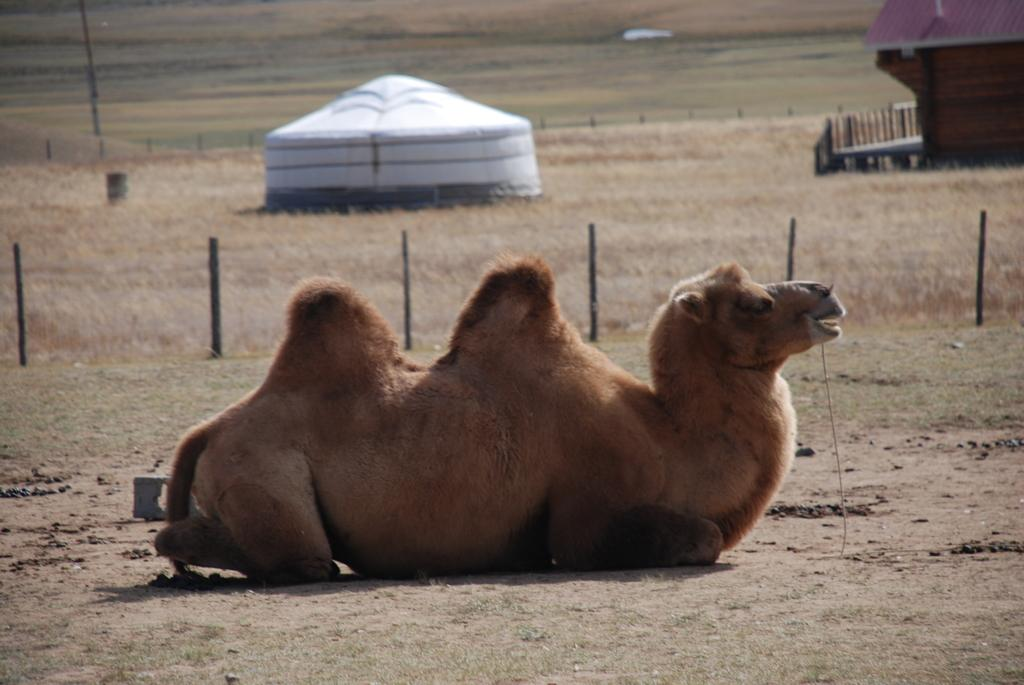What is the main subject in the center of the image? There is a camel in the center of the image. What structures are visible on the ground? There is a tent and a house on the ground. What type of vegetation is present on the ground? Grass and plants are visible on the ground. What type of barrier is present on the ground? There is fencing on the ground. What other object can be seen on the ground? There is a pole on the ground. What type of pie is being served on the pole in the image? There is no pie present in the image; the pole is a separate object without any food items. 